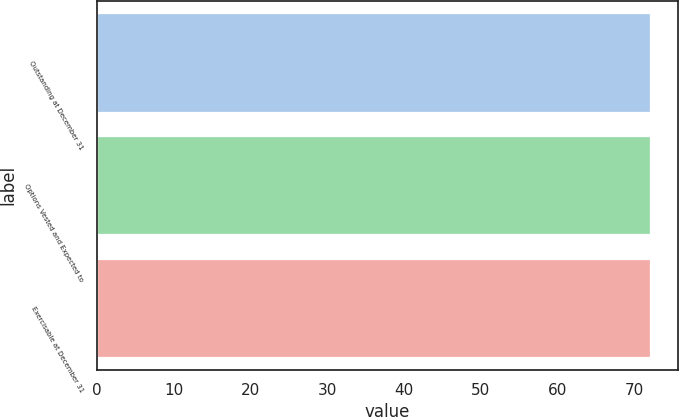Convert chart to OTSL. <chart><loc_0><loc_0><loc_500><loc_500><bar_chart><fcel>Outstanding at December 31<fcel>Options Vested and Expected to<fcel>Exercisable at December 31<nl><fcel>72.04<fcel>72.05<fcel>72.09<nl></chart> 